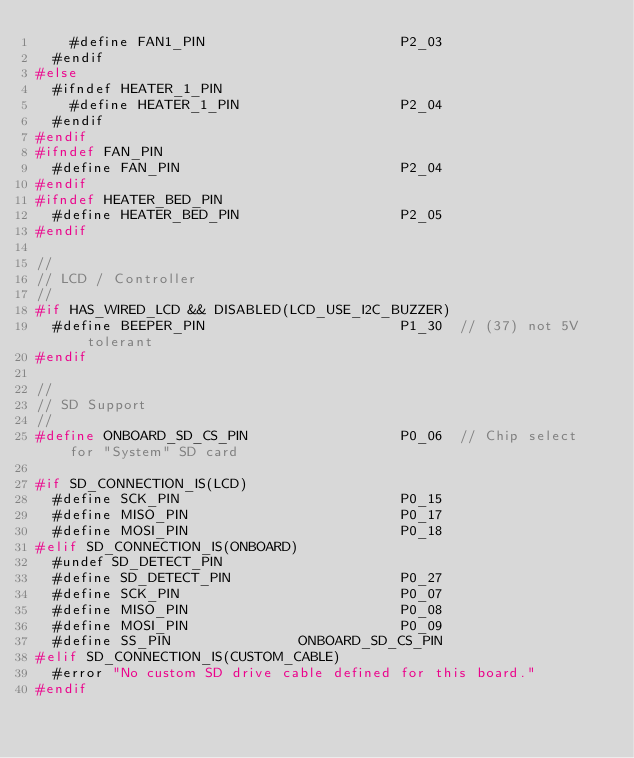Convert code to text. <code><loc_0><loc_0><loc_500><loc_500><_C_>    #define FAN1_PIN                       P2_03
  #endif
#else
  #ifndef HEATER_1_PIN
    #define HEATER_1_PIN                   P2_04
  #endif
#endif
#ifndef FAN_PIN
  #define FAN_PIN                          P2_04
#endif
#ifndef HEATER_BED_PIN
  #define HEATER_BED_PIN                   P2_05
#endif

//
// LCD / Controller
//
#if HAS_WIRED_LCD && DISABLED(LCD_USE_I2C_BUZZER)
  #define BEEPER_PIN                       P1_30  // (37) not 5V tolerant
#endif

//
// SD Support
//
#define ONBOARD_SD_CS_PIN                  P0_06  // Chip select for "System" SD card

#if SD_CONNECTION_IS(LCD)
  #define SCK_PIN                          P0_15
  #define MISO_PIN                         P0_17
  #define MOSI_PIN                         P0_18
#elif SD_CONNECTION_IS(ONBOARD)
  #undef SD_DETECT_PIN
  #define SD_DETECT_PIN                    P0_27
  #define SCK_PIN                          P0_07
  #define MISO_PIN                         P0_08
  #define MOSI_PIN                         P0_09
  #define SS_PIN               ONBOARD_SD_CS_PIN
#elif SD_CONNECTION_IS(CUSTOM_CABLE)
  #error "No custom SD drive cable defined for this board."
#endif
</code> 